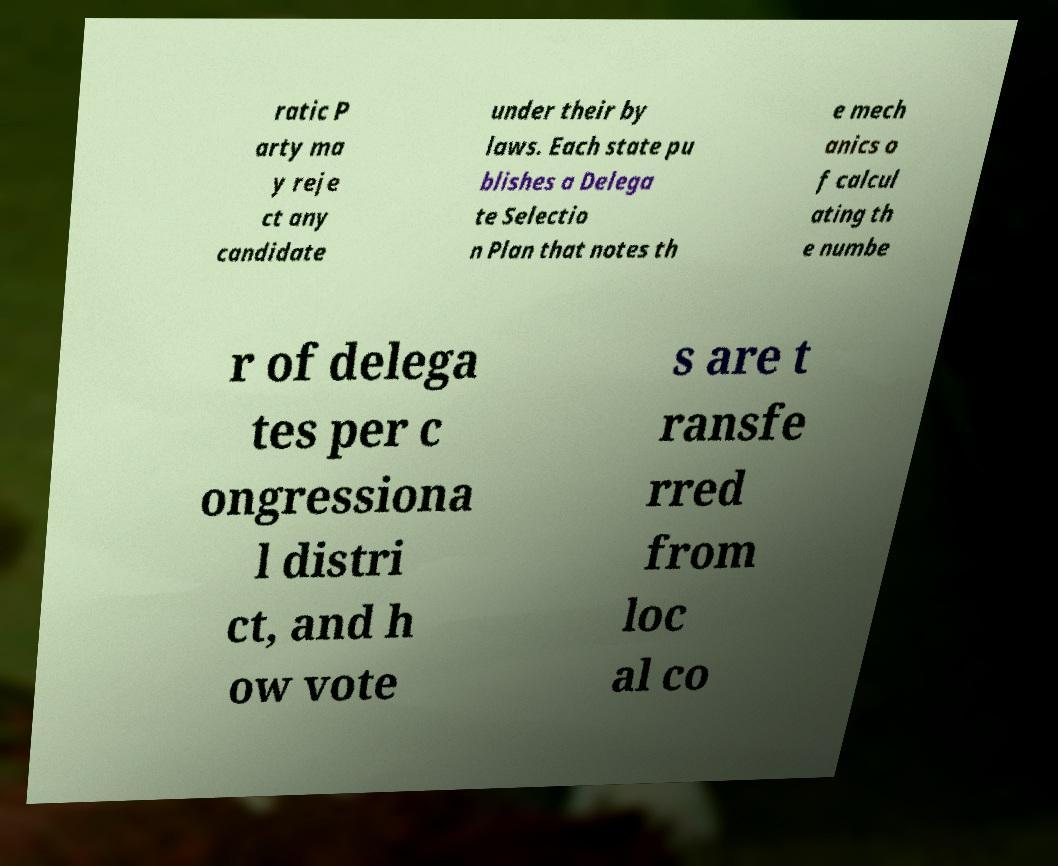What messages or text are displayed in this image? I need them in a readable, typed format. ratic P arty ma y reje ct any candidate under their by laws. Each state pu blishes a Delega te Selectio n Plan that notes th e mech anics o f calcul ating th e numbe r of delega tes per c ongressiona l distri ct, and h ow vote s are t ransfe rred from loc al co 